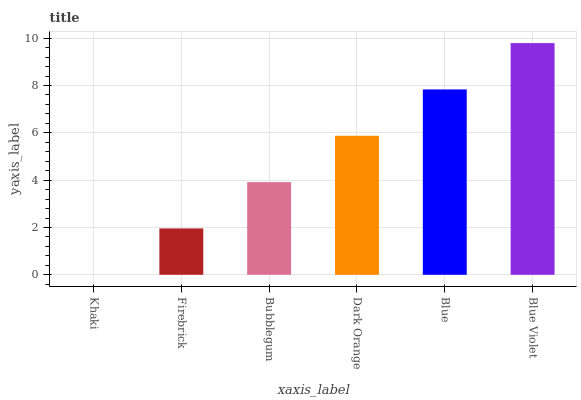Is Khaki the minimum?
Answer yes or no. Yes. Is Blue Violet the maximum?
Answer yes or no. Yes. Is Firebrick the minimum?
Answer yes or no. No. Is Firebrick the maximum?
Answer yes or no. No. Is Firebrick greater than Khaki?
Answer yes or no. Yes. Is Khaki less than Firebrick?
Answer yes or no. Yes. Is Khaki greater than Firebrick?
Answer yes or no. No. Is Firebrick less than Khaki?
Answer yes or no. No. Is Dark Orange the high median?
Answer yes or no. Yes. Is Bubblegum the low median?
Answer yes or no. Yes. Is Blue the high median?
Answer yes or no. No. Is Firebrick the low median?
Answer yes or no. No. 